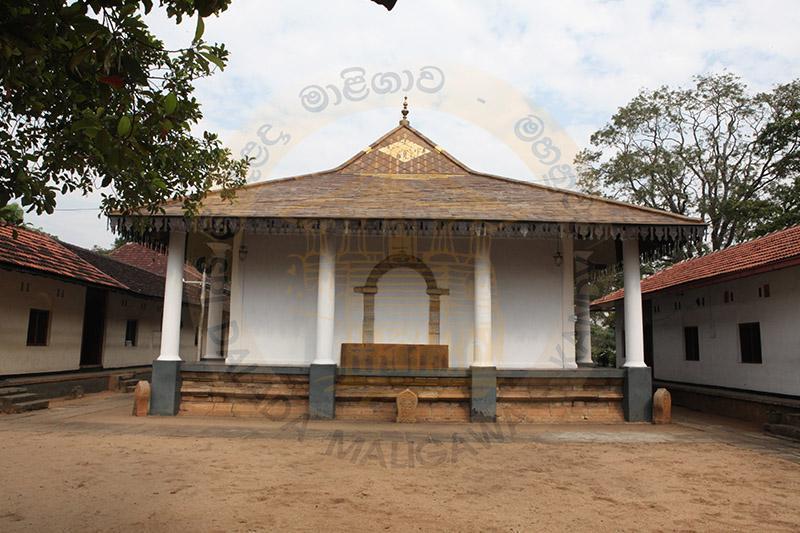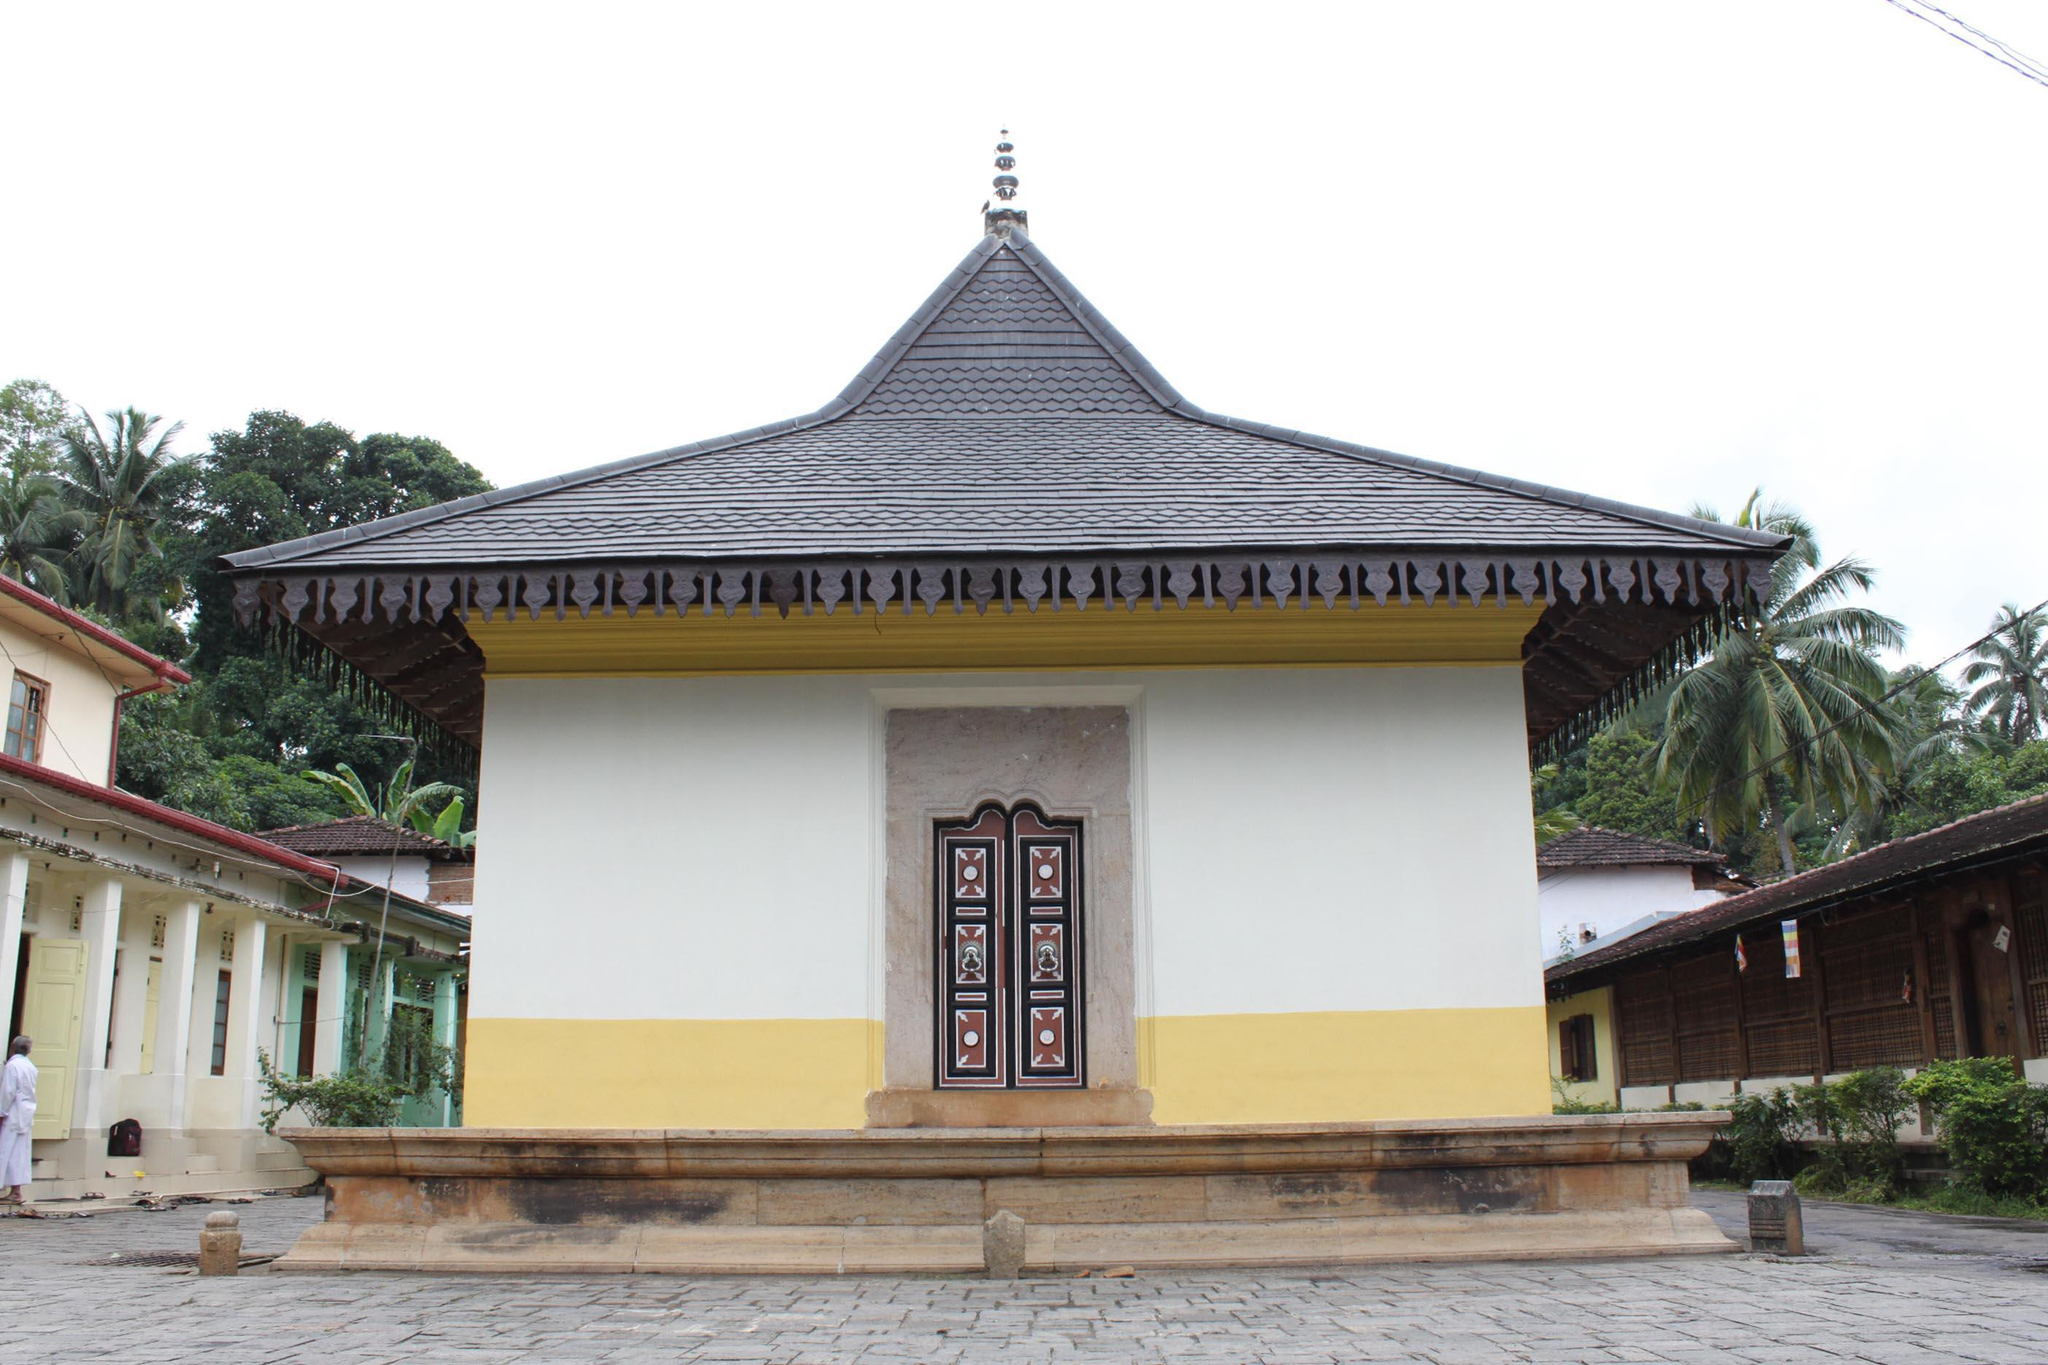The first image is the image on the left, the second image is the image on the right. Evaluate the accuracy of this statement regarding the images: "Each image shows an ornate building with a series of posts that support a roof hanging over a walkway that allows access to an entrance.". Is it true? Answer yes or no. No. The first image is the image on the left, the second image is the image on the right. Assess this claim about the two images: "There is at least one flag in front the building in at least one of the images.". Correct or not? Answer yes or no. No. 